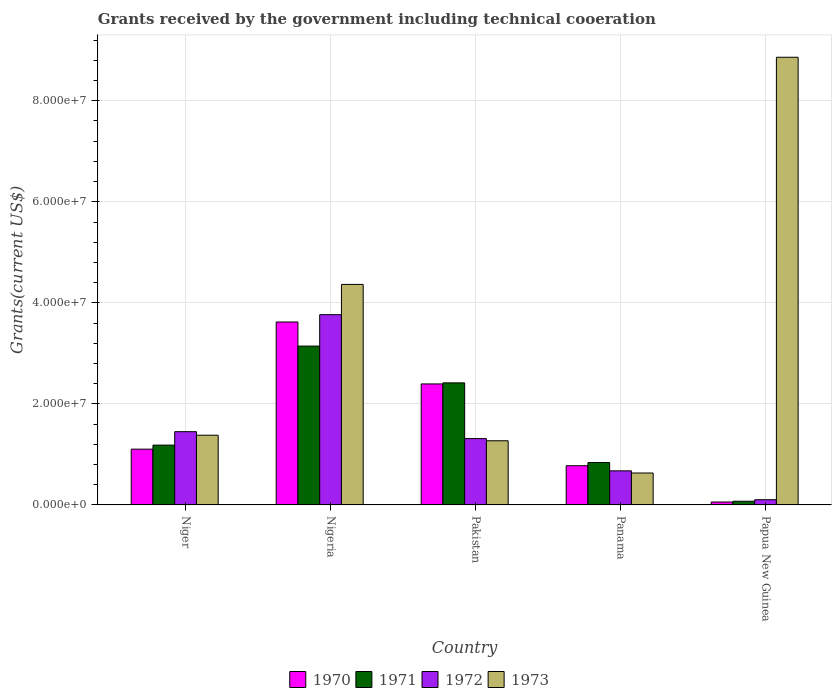How many different coloured bars are there?
Ensure brevity in your answer.  4. Are the number of bars on each tick of the X-axis equal?
Offer a terse response. Yes. What is the label of the 1st group of bars from the left?
Ensure brevity in your answer.  Niger. What is the total grants received by the government in 1970 in Pakistan?
Keep it short and to the point. 2.40e+07. Across all countries, what is the maximum total grants received by the government in 1970?
Give a very brief answer. 3.62e+07. Across all countries, what is the minimum total grants received by the government in 1970?
Your response must be concise. 5.80e+05. In which country was the total grants received by the government in 1973 maximum?
Offer a terse response. Papua New Guinea. In which country was the total grants received by the government in 1971 minimum?
Your answer should be compact. Papua New Guinea. What is the total total grants received by the government in 1973 in the graph?
Keep it short and to the point. 1.65e+08. What is the difference between the total grants received by the government in 1972 in Niger and that in Nigeria?
Give a very brief answer. -2.32e+07. What is the difference between the total grants received by the government in 1973 in Nigeria and the total grants received by the government in 1972 in Pakistan?
Your response must be concise. 3.05e+07. What is the average total grants received by the government in 1973 per country?
Your answer should be very brief. 3.30e+07. What is the difference between the total grants received by the government of/in 1970 and total grants received by the government of/in 1971 in Panama?
Your response must be concise. -6.30e+05. In how many countries, is the total grants received by the government in 1972 greater than 20000000 US$?
Keep it short and to the point. 1. What is the ratio of the total grants received by the government in 1971 in Pakistan to that in Papua New Guinea?
Give a very brief answer. 33.1. Is the difference between the total grants received by the government in 1970 in Panama and Papua New Guinea greater than the difference between the total grants received by the government in 1971 in Panama and Papua New Guinea?
Your answer should be compact. No. What is the difference between the highest and the second highest total grants received by the government in 1972?
Provide a short and direct response. 2.45e+07. What is the difference between the highest and the lowest total grants received by the government in 1973?
Offer a terse response. 8.23e+07. Is the sum of the total grants received by the government in 1970 in Nigeria and Panama greater than the maximum total grants received by the government in 1973 across all countries?
Provide a short and direct response. No. What does the 4th bar from the right in Panama represents?
Your answer should be very brief. 1970. Is it the case that in every country, the sum of the total grants received by the government in 1972 and total grants received by the government in 1973 is greater than the total grants received by the government in 1970?
Your answer should be very brief. Yes. What is the difference between two consecutive major ticks on the Y-axis?
Make the answer very short. 2.00e+07. Are the values on the major ticks of Y-axis written in scientific E-notation?
Make the answer very short. Yes. Does the graph contain any zero values?
Give a very brief answer. No. What is the title of the graph?
Your response must be concise. Grants received by the government including technical cooeration. What is the label or title of the Y-axis?
Ensure brevity in your answer.  Grants(current US$). What is the Grants(current US$) of 1970 in Niger?
Ensure brevity in your answer.  1.10e+07. What is the Grants(current US$) of 1971 in Niger?
Offer a very short reply. 1.18e+07. What is the Grants(current US$) in 1972 in Niger?
Offer a terse response. 1.45e+07. What is the Grants(current US$) of 1973 in Niger?
Your response must be concise. 1.38e+07. What is the Grants(current US$) of 1970 in Nigeria?
Your response must be concise. 3.62e+07. What is the Grants(current US$) in 1971 in Nigeria?
Provide a short and direct response. 3.14e+07. What is the Grants(current US$) in 1972 in Nigeria?
Ensure brevity in your answer.  3.77e+07. What is the Grants(current US$) of 1973 in Nigeria?
Provide a succinct answer. 4.36e+07. What is the Grants(current US$) in 1970 in Pakistan?
Ensure brevity in your answer.  2.40e+07. What is the Grants(current US$) in 1971 in Pakistan?
Your answer should be compact. 2.42e+07. What is the Grants(current US$) of 1972 in Pakistan?
Provide a succinct answer. 1.31e+07. What is the Grants(current US$) of 1973 in Pakistan?
Provide a short and direct response. 1.27e+07. What is the Grants(current US$) in 1970 in Panama?
Ensure brevity in your answer.  7.76e+06. What is the Grants(current US$) of 1971 in Panama?
Your answer should be compact. 8.39e+06. What is the Grants(current US$) in 1972 in Panama?
Provide a succinct answer. 6.75e+06. What is the Grants(current US$) of 1973 in Panama?
Give a very brief answer. 6.32e+06. What is the Grants(current US$) of 1970 in Papua New Guinea?
Your response must be concise. 5.80e+05. What is the Grants(current US$) of 1971 in Papua New Guinea?
Provide a succinct answer. 7.30e+05. What is the Grants(current US$) of 1972 in Papua New Guinea?
Ensure brevity in your answer.  1.03e+06. What is the Grants(current US$) of 1973 in Papua New Guinea?
Your response must be concise. 8.86e+07. Across all countries, what is the maximum Grants(current US$) in 1970?
Make the answer very short. 3.62e+07. Across all countries, what is the maximum Grants(current US$) in 1971?
Make the answer very short. 3.14e+07. Across all countries, what is the maximum Grants(current US$) in 1972?
Make the answer very short. 3.77e+07. Across all countries, what is the maximum Grants(current US$) of 1973?
Offer a very short reply. 8.86e+07. Across all countries, what is the minimum Grants(current US$) of 1970?
Your answer should be very brief. 5.80e+05. Across all countries, what is the minimum Grants(current US$) in 1971?
Provide a short and direct response. 7.30e+05. Across all countries, what is the minimum Grants(current US$) in 1972?
Offer a very short reply. 1.03e+06. Across all countries, what is the minimum Grants(current US$) in 1973?
Your response must be concise. 6.32e+06. What is the total Grants(current US$) in 1970 in the graph?
Your answer should be compact. 7.95e+07. What is the total Grants(current US$) in 1971 in the graph?
Offer a terse response. 7.66e+07. What is the total Grants(current US$) of 1972 in the graph?
Give a very brief answer. 7.31e+07. What is the total Grants(current US$) in 1973 in the graph?
Offer a terse response. 1.65e+08. What is the difference between the Grants(current US$) in 1970 in Niger and that in Nigeria?
Your response must be concise. -2.52e+07. What is the difference between the Grants(current US$) in 1971 in Niger and that in Nigeria?
Your answer should be very brief. -1.96e+07. What is the difference between the Grants(current US$) of 1972 in Niger and that in Nigeria?
Ensure brevity in your answer.  -2.32e+07. What is the difference between the Grants(current US$) in 1973 in Niger and that in Nigeria?
Give a very brief answer. -2.98e+07. What is the difference between the Grants(current US$) of 1970 in Niger and that in Pakistan?
Your response must be concise. -1.29e+07. What is the difference between the Grants(current US$) in 1971 in Niger and that in Pakistan?
Your answer should be very brief. -1.23e+07. What is the difference between the Grants(current US$) in 1972 in Niger and that in Pakistan?
Your response must be concise. 1.37e+06. What is the difference between the Grants(current US$) in 1973 in Niger and that in Pakistan?
Offer a very short reply. 1.10e+06. What is the difference between the Grants(current US$) of 1970 in Niger and that in Panama?
Your answer should be very brief. 3.28e+06. What is the difference between the Grants(current US$) in 1971 in Niger and that in Panama?
Give a very brief answer. 3.45e+06. What is the difference between the Grants(current US$) in 1972 in Niger and that in Panama?
Offer a terse response. 7.75e+06. What is the difference between the Grants(current US$) in 1973 in Niger and that in Panama?
Your answer should be very brief. 7.48e+06. What is the difference between the Grants(current US$) of 1970 in Niger and that in Papua New Guinea?
Your response must be concise. 1.05e+07. What is the difference between the Grants(current US$) in 1971 in Niger and that in Papua New Guinea?
Your response must be concise. 1.11e+07. What is the difference between the Grants(current US$) in 1972 in Niger and that in Papua New Guinea?
Ensure brevity in your answer.  1.35e+07. What is the difference between the Grants(current US$) in 1973 in Niger and that in Papua New Guinea?
Offer a very short reply. -7.48e+07. What is the difference between the Grants(current US$) of 1970 in Nigeria and that in Pakistan?
Provide a succinct answer. 1.23e+07. What is the difference between the Grants(current US$) of 1971 in Nigeria and that in Pakistan?
Your answer should be very brief. 7.28e+06. What is the difference between the Grants(current US$) of 1972 in Nigeria and that in Pakistan?
Provide a short and direct response. 2.45e+07. What is the difference between the Grants(current US$) of 1973 in Nigeria and that in Pakistan?
Your answer should be compact. 3.10e+07. What is the difference between the Grants(current US$) of 1970 in Nigeria and that in Panama?
Provide a short and direct response. 2.84e+07. What is the difference between the Grants(current US$) in 1971 in Nigeria and that in Panama?
Give a very brief answer. 2.30e+07. What is the difference between the Grants(current US$) in 1972 in Nigeria and that in Panama?
Provide a succinct answer. 3.09e+07. What is the difference between the Grants(current US$) in 1973 in Nigeria and that in Panama?
Your response must be concise. 3.73e+07. What is the difference between the Grants(current US$) in 1970 in Nigeria and that in Papua New Guinea?
Provide a short and direct response. 3.56e+07. What is the difference between the Grants(current US$) of 1971 in Nigeria and that in Papua New Guinea?
Your response must be concise. 3.07e+07. What is the difference between the Grants(current US$) of 1972 in Nigeria and that in Papua New Guinea?
Offer a terse response. 3.66e+07. What is the difference between the Grants(current US$) of 1973 in Nigeria and that in Papua New Guinea?
Make the answer very short. -4.50e+07. What is the difference between the Grants(current US$) of 1970 in Pakistan and that in Panama?
Provide a short and direct response. 1.62e+07. What is the difference between the Grants(current US$) in 1971 in Pakistan and that in Panama?
Make the answer very short. 1.58e+07. What is the difference between the Grants(current US$) of 1972 in Pakistan and that in Panama?
Offer a very short reply. 6.38e+06. What is the difference between the Grants(current US$) in 1973 in Pakistan and that in Panama?
Offer a terse response. 6.38e+06. What is the difference between the Grants(current US$) in 1970 in Pakistan and that in Papua New Guinea?
Your response must be concise. 2.34e+07. What is the difference between the Grants(current US$) in 1971 in Pakistan and that in Papua New Guinea?
Offer a very short reply. 2.34e+07. What is the difference between the Grants(current US$) of 1972 in Pakistan and that in Papua New Guinea?
Give a very brief answer. 1.21e+07. What is the difference between the Grants(current US$) in 1973 in Pakistan and that in Papua New Guinea?
Your response must be concise. -7.59e+07. What is the difference between the Grants(current US$) of 1970 in Panama and that in Papua New Guinea?
Keep it short and to the point. 7.18e+06. What is the difference between the Grants(current US$) of 1971 in Panama and that in Papua New Guinea?
Ensure brevity in your answer.  7.66e+06. What is the difference between the Grants(current US$) of 1972 in Panama and that in Papua New Guinea?
Provide a short and direct response. 5.72e+06. What is the difference between the Grants(current US$) in 1973 in Panama and that in Papua New Guinea?
Offer a terse response. -8.23e+07. What is the difference between the Grants(current US$) of 1970 in Niger and the Grants(current US$) of 1971 in Nigeria?
Offer a very short reply. -2.04e+07. What is the difference between the Grants(current US$) in 1970 in Niger and the Grants(current US$) in 1972 in Nigeria?
Ensure brevity in your answer.  -2.66e+07. What is the difference between the Grants(current US$) in 1970 in Niger and the Grants(current US$) in 1973 in Nigeria?
Keep it short and to the point. -3.26e+07. What is the difference between the Grants(current US$) in 1971 in Niger and the Grants(current US$) in 1972 in Nigeria?
Your response must be concise. -2.58e+07. What is the difference between the Grants(current US$) of 1971 in Niger and the Grants(current US$) of 1973 in Nigeria?
Give a very brief answer. -3.18e+07. What is the difference between the Grants(current US$) of 1972 in Niger and the Grants(current US$) of 1973 in Nigeria?
Keep it short and to the point. -2.92e+07. What is the difference between the Grants(current US$) in 1970 in Niger and the Grants(current US$) in 1971 in Pakistan?
Give a very brief answer. -1.31e+07. What is the difference between the Grants(current US$) of 1970 in Niger and the Grants(current US$) of 1972 in Pakistan?
Your answer should be very brief. -2.09e+06. What is the difference between the Grants(current US$) in 1970 in Niger and the Grants(current US$) in 1973 in Pakistan?
Provide a short and direct response. -1.66e+06. What is the difference between the Grants(current US$) of 1971 in Niger and the Grants(current US$) of 1972 in Pakistan?
Make the answer very short. -1.29e+06. What is the difference between the Grants(current US$) in 1971 in Niger and the Grants(current US$) in 1973 in Pakistan?
Your answer should be very brief. -8.60e+05. What is the difference between the Grants(current US$) of 1972 in Niger and the Grants(current US$) of 1973 in Pakistan?
Offer a very short reply. 1.80e+06. What is the difference between the Grants(current US$) in 1970 in Niger and the Grants(current US$) in 1971 in Panama?
Provide a succinct answer. 2.65e+06. What is the difference between the Grants(current US$) in 1970 in Niger and the Grants(current US$) in 1972 in Panama?
Offer a very short reply. 4.29e+06. What is the difference between the Grants(current US$) in 1970 in Niger and the Grants(current US$) in 1973 in Panama?
Offer a very short reply. 4.72e+06. What is the difference between the Grants(current US$) in 1971 in Niger and the Grants(current US$) in 1972 in Panama?
Your answer should be compact. 5.09e+06. What is the difference between the Grants(current US$) of 1971 in Niger and the Grants(current US$) of 1973 in Panama?
Ensure brevity in your answer.  5.52e+06. What is the difference between the Grants(current US$) in 1972 in Niger and the Grants(current US$) in 1973 in Panama?
Give a very brief answer. 8.18e+06. What is the difference between the Grants(current US$) in 1970 in Niger and the Grants(current US$) in 1971 in Papua New Guinea?
Offer a very short reply. 1.03e+07. What is the difference between the Grants(current US$) in 1970 in Niger and the Grants(current US$) in 1972 in Papua New Guinea?
Offer a very short reply. 1.00e+07. What is the difference between the Grants(current US$) of 1970 in Niger and the Grants(current US$) of 1973 in Papua New Guinea?
Make the answer very short. -7.76e+07. What is the difference between the Grants(current US$) of 1971 in Niger and the Grants(current US$) of 1972 in Papua New Guinea?
Make the answer very short. 1.08e+07. What is the difference between the Grants(current US$) in 1971 in Niger and the Grants(current US$) in 1973 in Papua New Guinea?
Your answer should be very brief. -7.68e+07. What is the difference between the Grants(current US$) in 1972 in Niger and the Grants(current US$) in 1973 in Papua New Guinea?
Provide a succinct answer. -7.41e+07. What is the difference between the Grants(current US$) in 1970 in Nigeria and the Grants(current US$) in 1971 in Pakistan?
Provide a succinct answer. 1.20e+07. What is the difference between the Grants(current US$) in 1970 in Nigeria and the Grants(current US$) in 1972 in Pakistan?
Keep it short and to the point. 2.31e+07. What is the difference between the Grants(current US$) of 1970 in Nigeria and the Grants(current US$) of 1973 in Pakistan?
Provide a short and direct response. 2.35e+07. What is the difference between the Grants(current US$) in 1971 in Nigeria and the Grants(current US$) in 1972 in Pakistan?
Provide a succinct answer. 1.83e+07. What is the difference between the Grants(current US$) of 1971 in Nigeria and the Grants(current US$) of 1973 in Pakistan?
Offer a very short reply. 1.87e+07. What is the difference between the Grants(current US$) of 1972 in Nigeria and the Grants(current US$) of 1973 in Pakistan?
Offer a very short reply. 2.50e+07. What is the difference between the Grants(current US$) in 1970 in Nigeria and the Grants(current US$) in 1971 in Panama?
Keep it short and to the point. 2.78e+07. What is the difference between the Grants(current US$) in 1970 in Nigeria and the Grants(current US$) in 1972 in Panama?
Keep it short and to the point. 2.95e+07. What is the difference between the Grants(current US$) in 1970 in Nigeria and the Grants(current US$) in 1973 in Panama?
Ensure brevity in your answer.  2.99e+07. What is the difference between the Grants(current US$) in 1971 in Nigeria and the Grants(current US$) in 1972 in Panama?
Ensure brevity in your answer.  2.47e+07. What is the difference between the Grants(current US$) in 1971 in Nigeria and the Grants(current US$) in 1973 in Panama?
Your answer should be very brief. 2.51e+07. What is the difference between the Grants(current US$) in 1972 in Nigeria and the Grants(current US$) in 1973 in Panama?
Your answer should be compact. 3.13e+07. What is the difference between the Grants(current US$) of 1970 in Nigeria and the Grants(current US$) of 1971 in Papua New Guinea?
Offer a very short reply. 3.55e+07. What is the difference between the Grants(current US$) in 1970 in Nigeria and the Grants(current US$) in 1972 in Papua New Guinea?
Make the answer very short. 3.52e+07. What is the difference between the Grants(current US$) of 1970 in Nigeria and the Grants(current US$) of 1973 in Papua New Guinea?
Offer a terse response. -5.24e+07. What is the difference between the Grants(current US$) of 1971 in Nigeria and the Grants(current US$) of 1972 in Papua New Guinea?
Offer a very short reply. 3.04e+07. What is the difference between the Grants(current US$) of 1971 in Nigeria and the Grants(current US$) of 1973 in Papua New Guinea?
Your answer should be compact. -5.72e+07. What is the difference between the Grants(current US$) of 1972 in Nigeria and the Grants(current US$) of 1973 in Papua New Guinea?
Make the answer very short. -5.10e+07. What is the difference between the Grants(current US$) of 1970 in Pakistan and the Grants(current US$) of 1971 in Panama?
Offer a terse response. 1.56e+07. What is the difference between the Grants(current US$) in 1970 in Pakistan and the Grants(current US$) in 1972 in Panama?
Keep it short and to the point. 1.72e+07. What is the difference between the Grants(current US$) of 1970 in Pakistan and the Grants(current US$) of 1973 in Panama?
Your answer should be compact. 1.76e+07. What is the difference between the Grants(current US$) in 1971 in Pakistan and the Grants(current US$) in 1972 in Panama?
Offer a terse response. 1.74e+07. What is the difference between the Grants(current US$) in 1971 in Pakistan and the Grants(current US$) in 1973 in Panama?
Your response must be concise. 1.78e+07. What is the difference between the Grants(current US$) in 1972 in Pakistan and the Grants(current US$) in 1973 in Panama?
Give a very brief answer. 6.81e+06. What is the difference between the Grants(current US$) of 1970 in Pakistan and the Grants(current US$) of 1971 in Papua New Guinea?
Your answer should be compact. 2.32e+07. What is the difference between the Grants(current US$) of 1970 in Pakistan and the Grants(current US$) of 1972 in Papua New Guinea?
Your answer should be very brief. 2.29e+07. What is the difference between the Grants(current US$) of 1970 in Pakistan and the Grants(current US$) of 1973 in Papua New Guinea?
Keep it short and to the point. -6.47e+07. What is the difference between the Grants(current US$) in 1971 in Pakistan and the Grants(current US$) in 1972 in Papua New Guinea?
Your response must be concise. 2.31e+07. What is the difference between the Grants(current US$) in 1971 in Pakistan and the Grants(current US$) in 1973 in Papua New Guinea?
Your response must be concise. -6.44e+07. What is the difference between the Grants(current US$) of 1972 in Pakistan and the Grants(current US$) of 1973 in Papua New Guinea?
Your answer should be compact. -7.55e+07. What is the difference between the Grants(current US$) of 1970 in Panama and the Grants(current US$) of 1971 in Papua New Guinea?
Offer a very short reply. 7.03e+06. What is the difference between the Grants(current US$) of 1970 in Panama and the Grants(current US$) of 1972 in Papua New Guinea?
Provide a short and direct response. 6.73e+06. What is the difference between the Grants(current US$) of 1970 in Panama and the Grants(current US$) of 1973 in Papua New Guinea?
Make the answer very short. -8.08e+07. What is the difference between the Grants(current US$) in 1971 in Panama and the Grants(current US$) in 1972 in Papua New Guinea?
Give a very brief answer. 7.36e+06. What is the difference between the Grants(current US$) in 1971 in Panama and the Grants(current US$) in 1973 in Papua New Guinea?
Provide a short and direct response. -8.02e+07. What is the difference between the Grants(current US$) of 1972 in Panama and the Grants(current US$) of 1973 in Papua New Guinea?
Ensure brevity in your answer.  -8.19e+07. What is the average Grants(current US$) in 1970 per country?
Offer a terse response. 1.59e+07. What is the average Grants(current US$) in 1971 per country?
Your answer should be compact. 1.53e+07. What is the average Grants(current US$) of 1972 per country?
Make the answer very short. 1.46e+07. What is the average Grants(current US$) of 1973 per country?
Make the answer very short. 3.30e+07. What is the difference between the Grants(current US$) in 1970 and Grants(current US$) in 1971 in Niger?
Ensure brevity in your answer.  -8.00e+05. What is the difference between the Grants(current US$) in 1970 and Grants(current US$) in 1972 in Niger?
Give a very brief answer. -3.46e+06. What is the difference between the Grants(current US$) in 1970 and Grants(current US$) in 1973 in Niger?
Keep it short and to the point. -2.76e+06. What is the difference between the Grants(current US$) in 1971 and Grants(current US$) in 1972 in Niger?
Provide a succinct answer. -2.66e+06. What is the difference between the Grants(current US$) in 1971 and Grants(current US$) in 1973 in Niger?
Your answer should be compact. -1.96e+06. What is the difference between the Grants(current US$) in 1972 and Grants(current US$) in 1973 in Niger?
Offer a very short reply. 7.00e+05. What is the difference between the Grants(current US$) of 1970 and Grants(current US$) of 1971 in Nigeria?
Keep it short and to the point. 4.77e+06. What is the difference between the Grants(current US$) of 1970 and Grants(current US$) of 1972 in Nigeria?
Give a very brief answer. -1.45e+06. What is the difference between the Grants(current US$) of 1970 and Grants(current US$) of 1973 in Nigeria?
Make the answer very short. -7.44e+06. What is the difference between the Grants(current US$) in 1971 and Grants(current US$) in 1972 in Nigeria?
Your answer should be very brief. -6.22e+06. What is the difference between the Grants(current US$) of 1971 and Grants(current US$) of 1973 in Nigeria?
Ensure brevity in your answer.  -1.22e+07. What is the difference between the Grants(current US$) of 1972 and Grants(current US$) of 1973 in Nigeria?
Keep it short and to the point. -5.99e+06. What is the difference between the Grants(current US$) in 1970 and Grants(current US$) in 1972 in Pakistan?
Make the answer very short. 1.08e+07. What is the difference between the Grants(current US$) in 1970 and Grants(current US$) in 1973 in Pakistan?
Your answer should be compact. 1.12e+07. What is the difference between the Grants(current US$) of 1971 and Grants(current US$) of 1972 in Pakistan?
Provide a short and direct response. 1.10e+07. What is the difference between the Grants(current US$) of 1971 and Grants(current US$) of 1973 in Pakistan?
Ensure brevity in your answer.  1.15e+07. What is the difference between the Grants(current US$) in 1970 and Grants(current US$) in 1971 in Panama?
Your response must be concise. -6.30e+05. What is the difference between the Grants(current US$) of 1970 and Grants(current US$) of 1972 in Panama?
Your answer should be very brief. 1.01e+06. What is the difference between the Grants(current US$) of 1970 and Grants(current US$) of 1973 in Panama?
Offer a very short reply. 1.44e+06. What is the difference between the Grants(current US$) of 1971 and Grants(current US$) of 1972 in Panama?
Offer a terse response. 1.64e+06. What is the difference between the Grants(current US$) of 1971 and Grants(current US$) of 1973 in Panama?
Your answer should be very brief. 2.07e+06. What is the difference between the Grants(current US$) in 1970 and Grants(current US$) in 1972 in Papua New Guinea?
Ensure brevity in your answer.  -4.50e+05. What is the difference between the Grants(current US$) of 1970 and Grants(current US$) of 1973 in Papua New Guinea?
Your answer should be very brief. -8.80e+07. What is the difference between the Grants(current US$) of 1971 and Grants(current US$) of 1972 in Papua New Guinea?
Your answer should be very brief. -3.00e+05. What is the difference between the Grants(current US$) of 1971 and Grants(current US$) of 1973 in Papua New Guinea?
Offer a terse response. -8.79e+07. What is the difference between the Grants(current US$) in 1972 and Grants(current US$) in 1973 in Papua New Guinea?
Your answer should be very brief. -8.76e+07. What is the ratio of the Grants(current US$) in 1970 in Niger to that in Nigeria?
Make the answer very short. 0.3. What is the ratio of the Grants(current US$) of 1971 in Niger to that in Nigeria?
Your answer should be very brief. 0.38. What is the ratio of the Grants(current US$) of 1972 in Niger to that in Nigeria?
Provide a short and direct response. 0.39. What is the ratio of the Grants(current US$) of 1973 in Niger to that in Nigeria?
Offer a very short reply. 0.32. What is the ratio of the Grants(current US$) of 1970 in Niger to that in Pakistan?
Your answer should be very brief. 0.46. What is the ratio of the Grants(current US$) in 1971 in Niger to that in Pakistan?
Make the answer very short. 0.49. What is the ratio of the Grants(current US$) in 1972 in Niger to that in Pakistan?
Provide a short and direct response. 1.1. What is the ratio of the Grants(current US$) in 1973 in Niger to that in Pakistan?
Make the answer very short. 1.09. What is the ratio of the Grants(current US$) in 1970 in Niger to that in Panama?
Make the answer very short. 1.42. What is the ratio of the Grants(current US$) in 1971 in Niger to that in Panama?
Offer a terse response. 1.41. What is the ratio of the Grants(current US$) of 1972 in Niger to that in Panama?
Give a very brief answer. 2.15. What is the ratio of the Grants(current US$) of 1973 in Niger to that in Panama?
Your answer should be very brief. 2.18. What is the ratio of the Grants(current US$) in 1970 in Niger to that in Papua New Guinea?
Offer a terse response. 19.03. What is the ratio of the Grants(current US$) of 1971 in Niger to that in Papua New Guinea?
Offer a very short reply. 16.22. What is the ratio of the Grants(current US$) of 1972 in Niger to that in Papua New Guinea?
Keep it short and to the point. 14.08. What is the ratio of the Grants(current US$) of 1973 in Niger to that in Papua New Guinea?
Offer a terse response. 0.16. What is the ratio of the Grants(current US$) of 1970 in Nigeria to that in Pakistan?
Offer a terse response. 1.51. What is the ratio of the Grants(current US$) in 1971 in Nigeria to that in Pakistan?
Your response must be concise. 1.3. What is the ratio of the Grants(current US$) of 1972 in Nigeria to that in Pakistan?
Your response must be concise. 2.87. What is the ratio of the Grants(current US$) of 1973 in Nigeria to that in Pakistan?
Provide a succinct answer. 3.44. What is the ratio of the Grants(current US$) in 1970 in Nigeria to that in Panama?
Your answer should be very brief. 4.67. What is the ratio of the Grants(current US$) of 1971 in Nigeria to that in Panama?
Ensure brevity in your answer.  3.75. What is the ratio of the Grants(current US$) in 1972 in Nigeria to that in Panama?
Provide a succinct answer. 5.58. What is the ratio of the Grants(current US$) in 1973 in Nigeria to that in Panama?
Offer a very short reply. 6.91. What is the ratio of the Grants(current US$) of 1970 in Nigeria to that in Papua New Guinea?
Provide a succinct answer. 62.43. What is the ratio of the Grants(current US$) in 1971 in Nigeria to that in Papua New Guinea?
Keep it short and to the point. 43.07. What is the ratio of the Grants(current US$) in 1972 in Nigeria to that in Papua New Guinea?
Offer a terse response. 36.56. What is the ratio of the Grants(current US$) in 1973 in Nigeria to that in Papua New Guinea?
Keep it short and to the point. 0.49. What is the ratio of the Grants(current US$) in 1970 in Pakistan to that in Panama?
Provide a short and direct response. 3.09. What is the ratio of the Grants(current US$) of 1971 in Pakistan to that in Panama?
Ensure brevity in your answer.  2.88. What is the ratio of the Grants(current US$) of 1972 in Pakistan to that in Panama?
Ensure brevity in your answer.  1.95. What is the ratio of the Grants(current US$) of 1973 in Pakistan to that in Panama?
Give a very brief answer. 2.01. What is the ratio of the Grants(current US$) of 1970 in Pakistan to that in Papua New Guinea?
Ensure brevity in your answer.  41.29. What is the ratio of the Grants(current US$) of 1971 in Pakistan to that in Papua New Guinea?
Ensure brevity in your answer.  33.1. What is the ratio of the Grants(current US$) in 1972 in Pakistan to that in Papua New Guinea?
Your answer should be compact. 12.75. What is the ratio of the Grants(current US$) of 1973 in Pakistan to that in Papua New Guinea?
Your response must be concise. 0.14. What is the ratio of the Grants(current US$) in 1970 in Panama to that in Papua New Guinea?
Give a very brief answer. 13.38. What is the ratio of the Grants(current US$) of 1971 in Panama to that in Papua New Guinea?
Your answer should be compact. 11.49. What is the ratio of the Grants(current US$) of 1972 in Panama to that in Papua New Guinea?
Ensure brevity in your answer.  6.55. What is the ratio of the Grants(current US$) of 1973 in Panama to that in Papua New Guinea?
Provide a short and direct response. 0.07. What is the difference between the highest and the second highest Grants(current US$) in 1970?
Your answer should be very brief. 1.23e+07. What is the difference between the highest and the second highest Grants(current US$) of 1971?
Give a very brief answer. 7.28e+06. What is the difference between the highest and the second highest Grants(current US$) of 1972?
Give a very brief answer. 2.32e+07. What is the difference between the highest and the second highest Grants(current US$) in 1973?
Provide a succinct answer. 4.50e+07. What is the difference between the highest and the lowest Grants(current US$) in 1970?
Provide a succinct answer. 3.56e+07. What is the difference between the highest and the lowest Grants(current US$) in 1971?
Your response must be concise. 3.07e+07. What is the difference between the highest and the lowest Grants(current US$) in 1972?
Your answer should be compact. 3.66e+07. What is the difference between the highest and the lowest Grants(current US$) in 1973?
Offer a very short reply. 8.23e+07. 